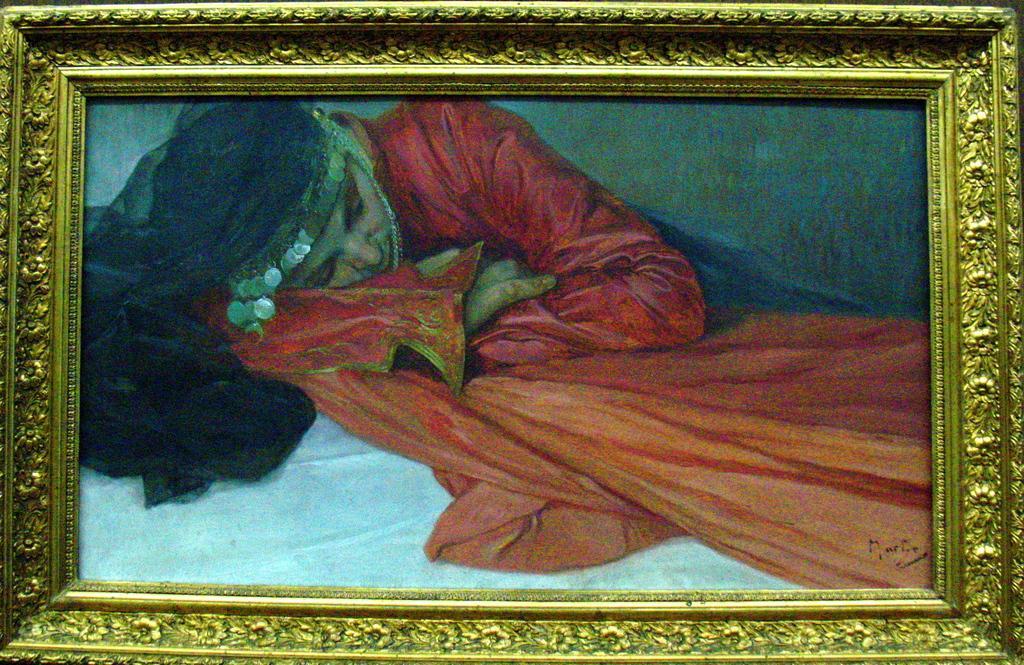Please provide a concise description of this image. In this picture there is a frame. In the frame there is a picture of a lying woman with red dress, at the bottom there is a white bed. 